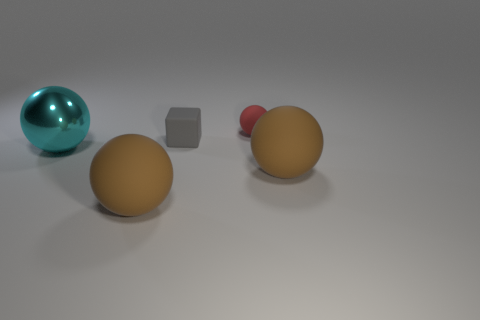How many objects in total can you see in this image? There are five objects present in total; two large brown spheres, one small red sphere, one teal reflective sphere, and one gray cube. Can you tell which object is the closest to the camera? The closest object to the camera appears to be the large brown sphere on the left side of the image. 